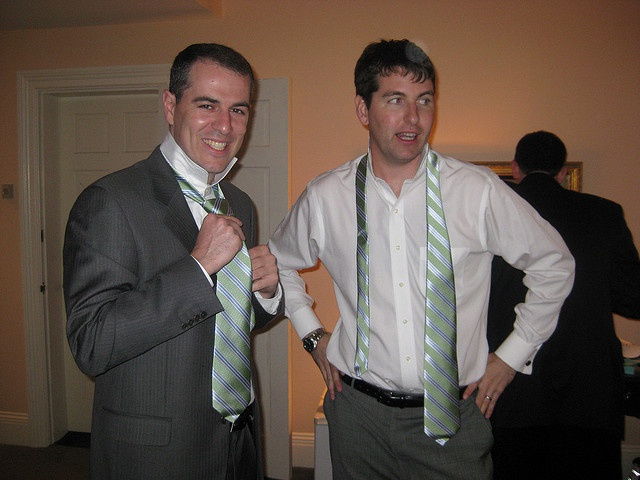Describe the objects in this image and their specific colors. I can see people in black, darkgray, and gray tones, people in black, gray, brown, and darkgray tones, people in black, gray, and maroon tones, tie in black, darkgray, and gray tones, and tie in black, darkgray, and gray tones in this image. 